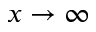<formula> <loc_0><loc_0><loc_500><loc_500>x \to \infty</formula> 